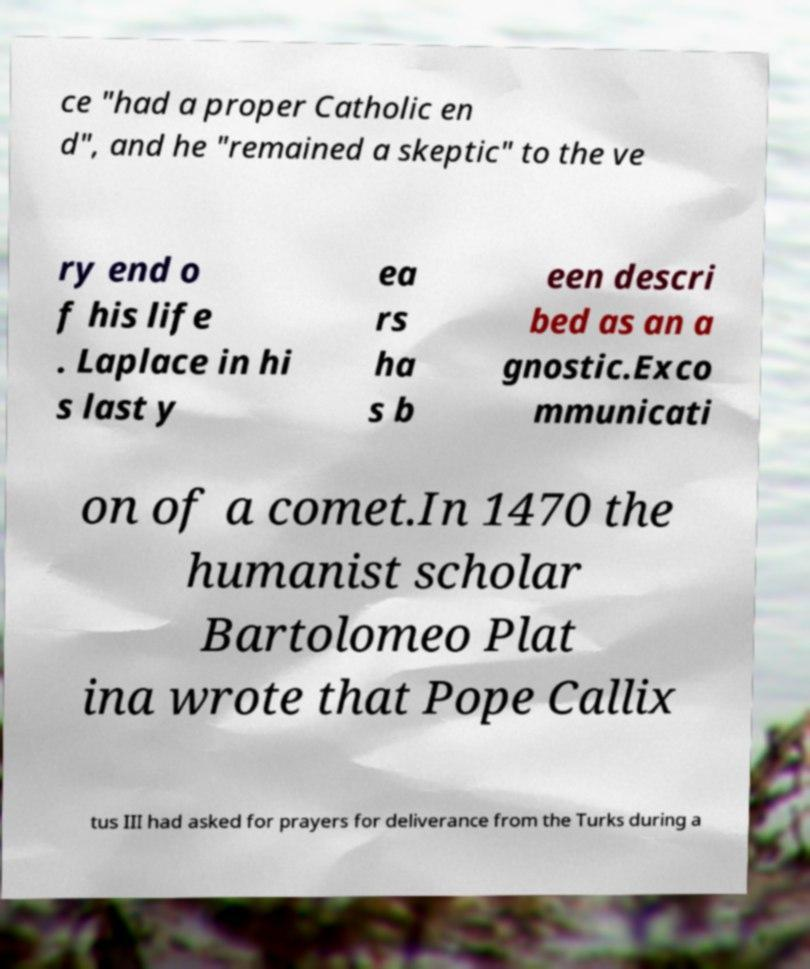Please identify and transcribe the text found in this image. ce "had a proper Catholic en d", and he "remained a skeptic" to the ve ry end o f his life . Laplace in hi s last y ea rs ha s b een descri bed as an a gnostic.Exco mmunicati on of a comet.In 1470 the humanist scholar Bartolomeo Plat ina wrote that Pope Callix tus III had asked for prayers for deliverance from the Turks during a 